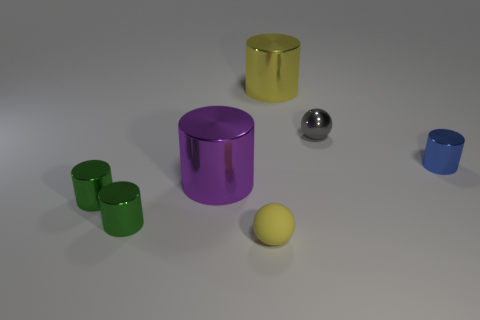Subtract all yellow cylinders. How many cylinders are left? 4 Add 2 yellow matte balls. How many objects exist? 9 Subtract 2 balls. How many balls are left? 0 Subtract all gray spheres. How many spheres are left? 1 Subtract all cylinders. How many objects are left? 2 Subtract all yellow cubes. How many green cylinders are left? 2 Add 7 small gray things. How many small gray things are left? 8 Add 2 tiny metallic cylinders. How many tiny metallic cylinders exist? 5 Subtract 0 blue cubes. How many objects are left? 7 Subtract all green balls. Subtract all brown cylinders. How many balls are left? 2 